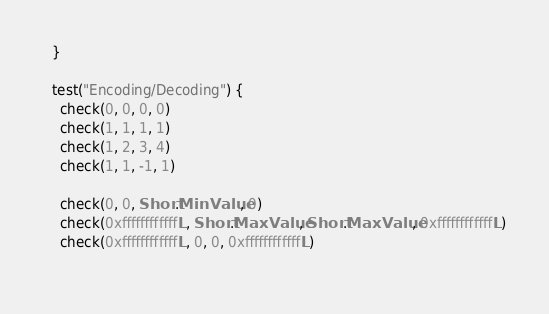Convert code to text. <code><loc_0><loc_0><loc_500><loc_500><_Scala_>  }

  test("Encoding/Decoding") {
    check(0, 0, 0, 0)
    check(1, 1, 1, 1)
    check(1, 2, 3, 4)
    check(1, 1, -1, 1)
    
    check(0, 0, Short.MinValue, 0)
    check(0xffffffffffffL, Short.MaxValue, Short.MaxValue, 0xffffffffffffL)
    check(0xffffffffffffL, 0, 0, 0xffffffffffffL)
    </code> 